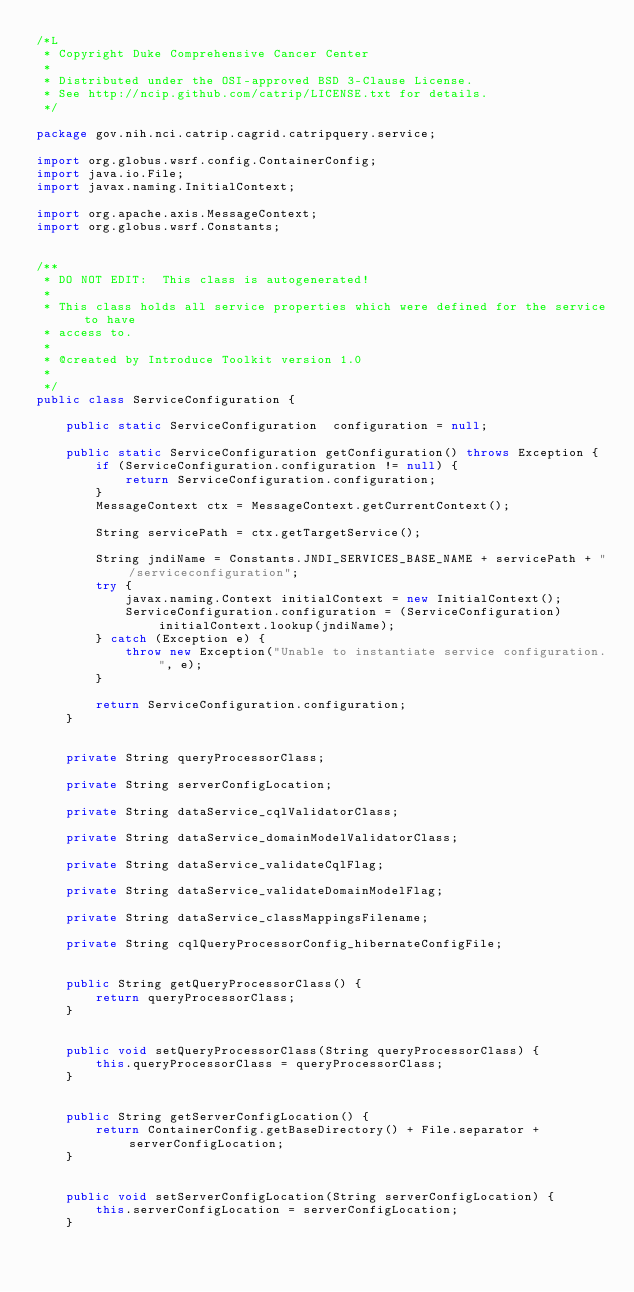Convert code to text. <code><loc_0><loc_0><loc_500><loc_500><_Java_>/*L
 * Copyright Duke Comprehensive Cancer Center
 *
 * Distributed under the OSI-approved BSD 3-Clause License.
 * See http://ncip.github.com/catrip/LICENSE.txt for details.
 */

package gov.nih.nci.catrip.cagrid.catripquery.service;

import org.globus.wsrf.config.ContainerConfig;
import java.io.File;
import javax.naming.InitialContext;

import org.apache.axis.MessageContext;
import org.globus.wsrf.Constants;


/** 
 * DO NOT EDIT:  This class is autogenerated!
 * 
 * This class holds all service properties which were defined for the service to have
 * access to.
 * 
 * @created by Introduce Toolkit version 1.0
 * 
 */
public class ServiceConfiguration {

	public static ServiceConfiguration  configuration = null;

	public static ServiceConfiguration getConfiguration() throws Exception {
		if (ServiceConfiguration.configuration != null) {
			return ServiceConfiguration.configuration;
		}
		MessageContext ctx = MessageContext.getCurrentContext();

		String servicePath = ctx.getTargetService();

		String jndiName = Constants.JNDI_SERVICES_BASE_NAME + servicePath + "/serviceconfiguration";
		try {
			javax.naming.Context initialContext = new InitialContext();
			ServiceConfiguration.configuration = (ServiceConfiguration) initialContext.lookup(jndiName);
		} catch (Exception e) {
			throw new Exception("Unable to instantiate service configuration.", e);
		}

		return ServiceConfiguration.configuration;
	}
	
	
	private String queryProcessorClass;
	
	private String serverConfigLocation;
	
	private String dataService_cqlValidatorClass;
	
	private String dataService_domainModelValidatorClass;
	
	private String dataService_validateCqlFlag;
	
	private String dataService_validateDomainModelFlag;
	
	private String dataService_classMappingsFilename;
	
	private String cqlQueryProcessorConfig_hibernateConfigFile;

	
	public String getQueryProcessorClass() {
		return queryProcessorClass;
	}
	
	
	public void setQueryProcessorClass(String queryProcessorClass) {
		this.queryProcessorClass = queryProcessorClass;
	}

	
	public String getServerConfigLocation() {
		return ContainerConfig.getBaseDirectory() + File.separator + serverConfigLocation;
	}
	
	
	public void setServerConfigLocation(String serverConfigLocation) {
		this.serverConfigLocation = serverConfigLocation;
	}
</code> 